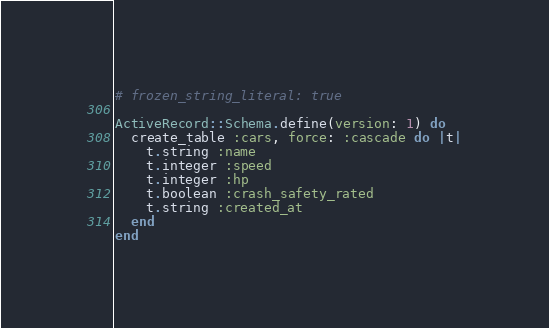<code> <loc_0><loc_0><loc_500><loc_500><_Ruby_># frozen_string_literal: true

ActiveRecord::Schema.define(version: 1) do
  create_table :cars, force: :cascade do |t|
    t.string :name
    t.integer :speed
    t.integer :hp
    t.boolean :crash_safety_rated
    t.string :created_at
  end
end
</code> 